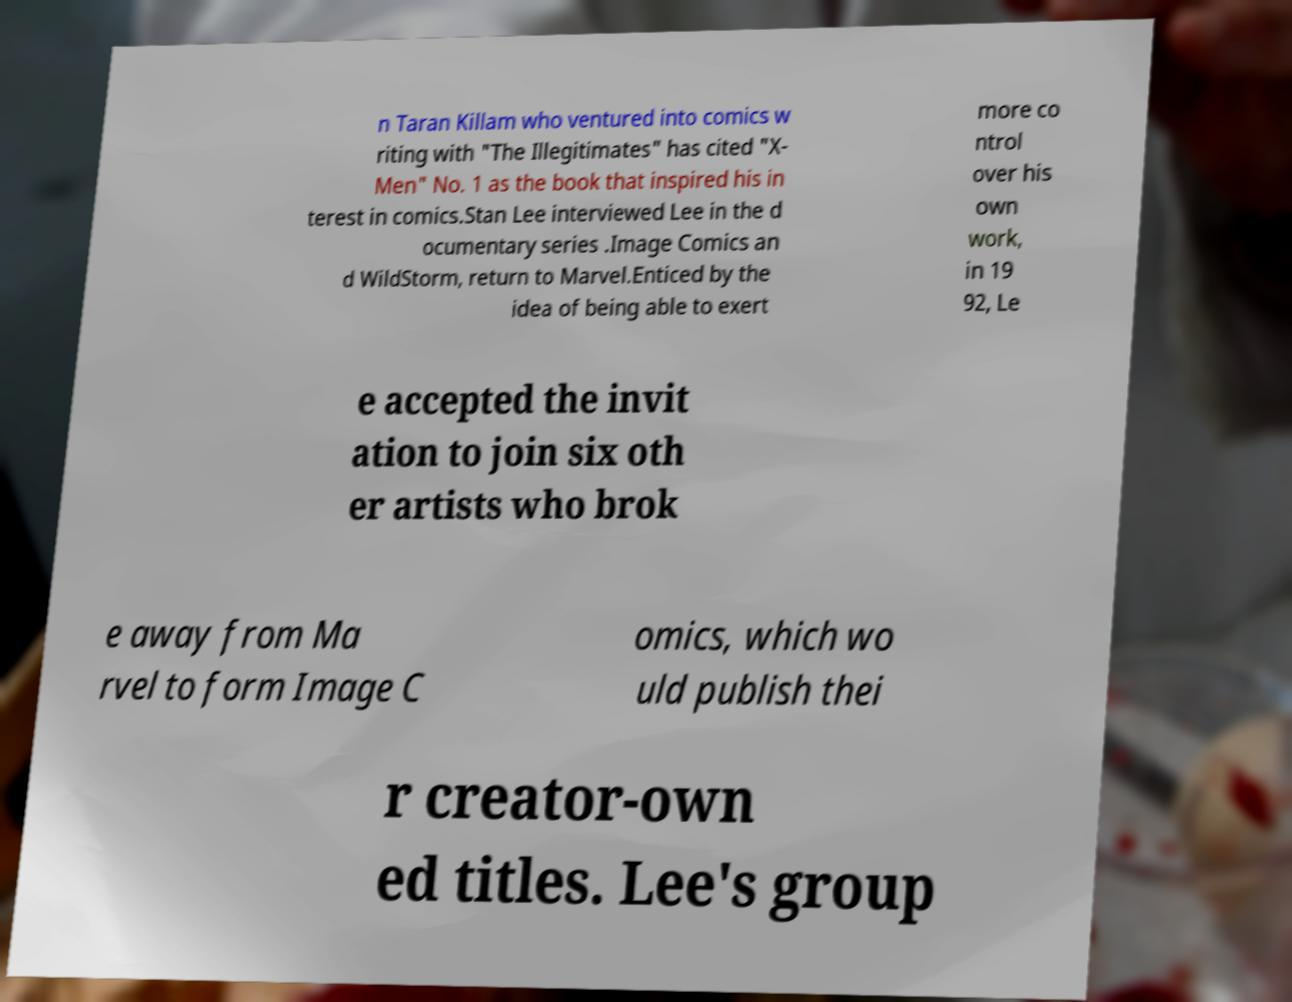Please read and relay the text visible in this image. What does it say? n Taran Killam who ventured into comics w riting with "The Illegitimates" has cited "X- Men" No. 1 as the book that inspired his in terest in comics.Stan Lee interviewed Lee in the d ocumentary series .Image Comics an d WildStorm, return to Marvel.Enticed by the idea of being able to exert more co ntrol over his own work, in 19 92, Le e accepted the invit ation to join six oth er artists who brok e away from Ma rvel to form Image C omics, which wo uld publish thei r creator-own ed titles. Lee's group 